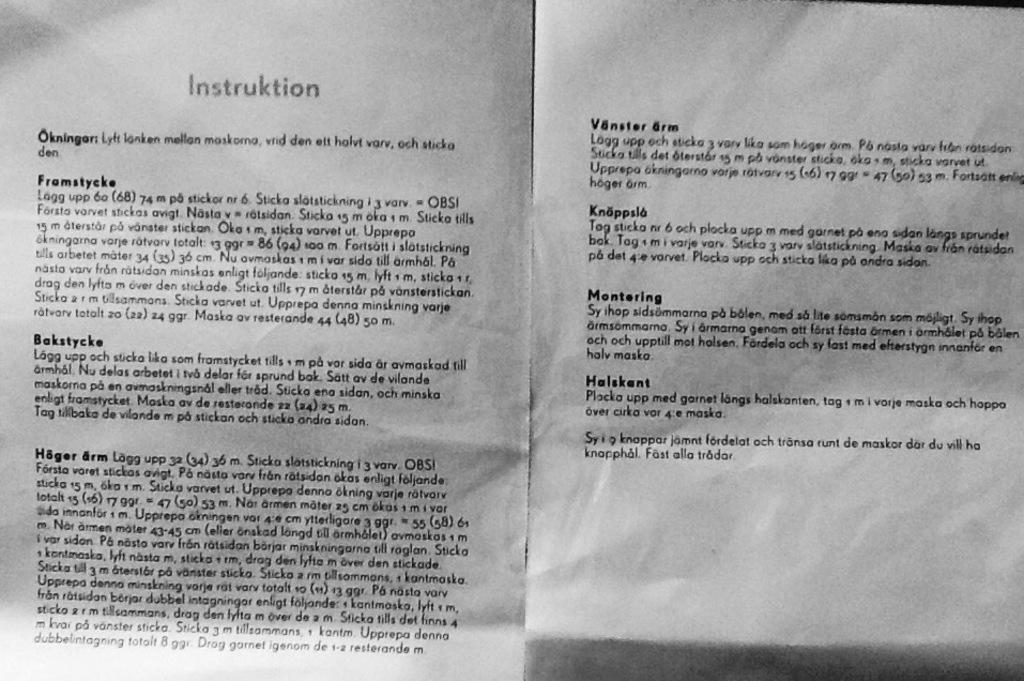<image>
Offer a succinct explanation of the picture presented. White pieces of paper with Instruktion written in gray 